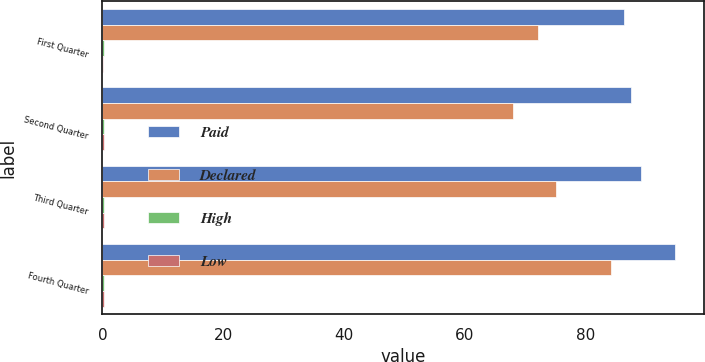<chart> <loc_0><loc_0><loc_500><loc_500><stacked_bar_chart><ecel><fcel>First Quarter<fcel>Second Quarter<fcel>Third Quarter<fcel>Fourth Quarter<nl><fcel>Paid<fcel>86.35<fcel>87.57<fcel>89.17<fcel>94.84<nl><fcel>Declared<fcel>72.2<fcel>67.91<fcel>75.07<fcel>84.15<nl><fcel>High<fcel>0.2<fcel>0.2<fcel>0.2<fcel>0.2<nl><fcel>Low<fcel>0.17<fcel>0.2<fcel>0.2<fcel>0.2<nl></chart> 